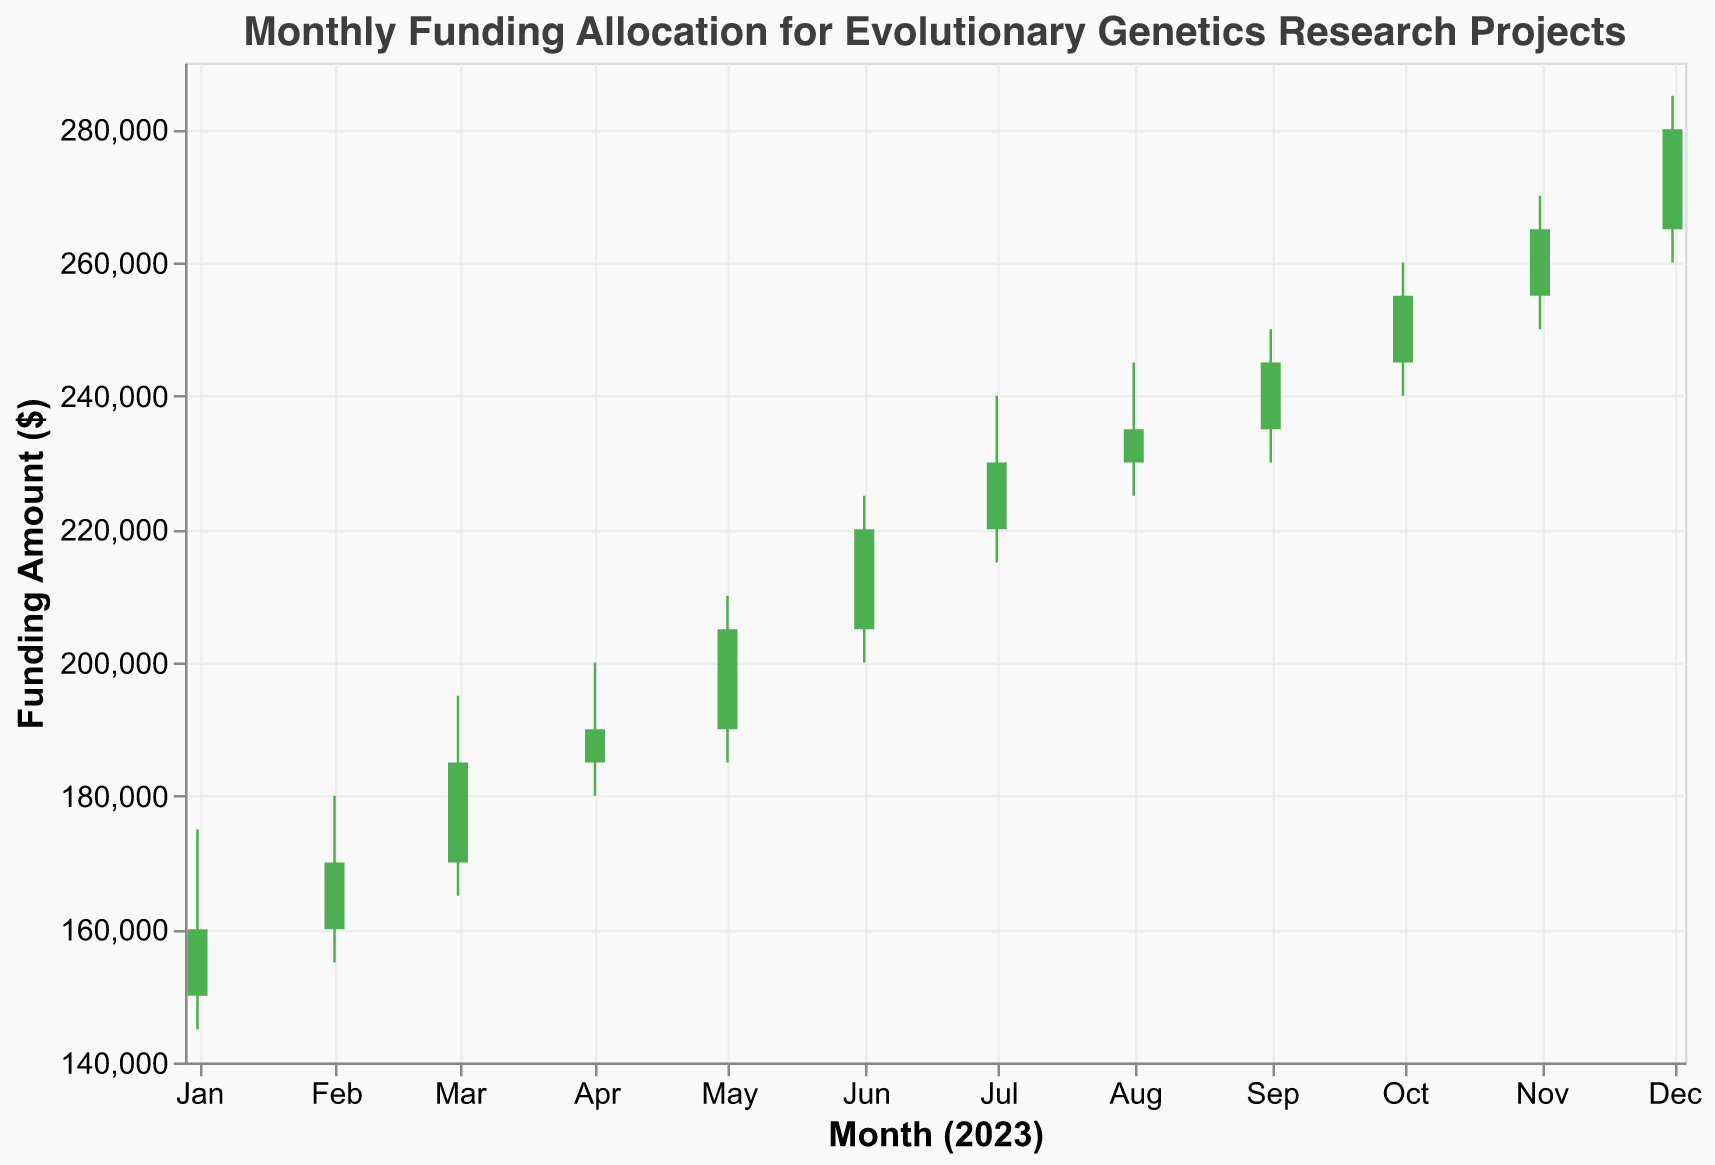What's the title of the figure? The title of the figure is typically located at the top, and it summarizes the content of the chart. In this case, the title states "Monthly Funding Allocation for Evolutionary Genetics Research Projects."
Answer: Monthly Funding Allocation for Evolutionary Genetics Research Projects What is the highest funding amount attained in 2023? The highest funding amount is represented by the highest point on the vertical axis labeled "Funding Amount ($)." The maximum value marked on the chart in 2023 is $285,000 in December.
Answer: $285,000 In which month did the lowest funding amount occur? To determine this, identify the month with the lowest value on the vertical axis. The lowest funding amount is $145,000 in January.
Answer: January What's the difference between the opening and closing funding amounts in March? The opening funding amount for March is $170,000, and the closing amount is $185,000. Subtracting the opening amount from the closing amount gives $185,000 - $170,000 = $15,000.
Answer: $15,000 Which months saw an increase in funding from opening to closing? The months where the "Close" value is higher than the "Open" value indicate an increase in funding. By examining the chart: January (increased), February (increased), March (increased), April (increased), May (increased), June (increased), July (increased), August (increased), September (increased), October (increased), November (increased), and December (increased).
Answer: All months saw an increase What's the average closing funding amount over the entire year? Sum the closing funding amounts over each month and divide by the number of months. Total = $160,000 + $170,000 + $185,000 + $190,000 + $205,000 + $220,000 + $230,000 + $235,000 + $245,000 + $255,000 + $265,000 + $280,000 = $2,640,000. Average = $2,640,000 / 12 = $220,000.
Answer: $220,000 Between which two consecutive months was the highest increase in funding allocated? Calculate the difference in closing amounts between each pair of consecutive months and find the largest. The biggest increase occurs from November ($265,000) to December ($280,000), with an increase of $15,000.
Answer: From November to December Which months had the highest volatility in funding allocation? Volatility can be assessed by looking at the range between the high and low values in each month. Considering all months, December has the highest volatility with a range from $260,000 to $285,000 (range = $25,000).
Answer: December How did the funding allocation trend evolve over the year? By examining the overall movement from January to December, it's clear that there was a steady increase in both the opening and closing funding amounts throughout the year.
Answer: The funding increased steadily over the year What's the sum of the highest funding amounts throughout the year? Sum the highest funding amounts recorded each month. Total = $175,000 + $180,000 + $195,000 + $200,000 + $210,000 + $225,000 + $240,000 + $245,000 + $250,000 + $260,000 + $270,000 + $285,000 = $2,935,000.
Answer: $2,935,000 